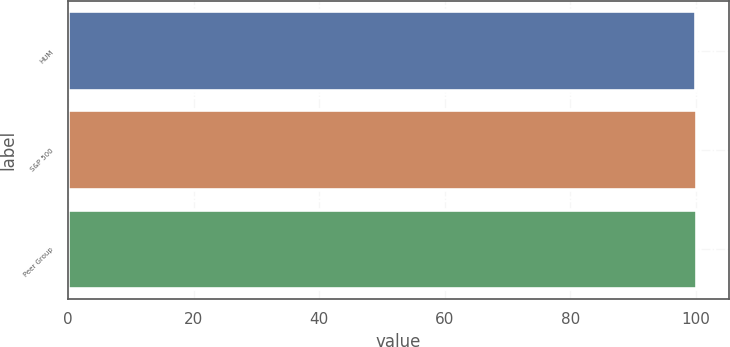Convert chart to OTSL. <chart><loc_0><loc_0><loc_500><loc_500><bar_chart><fcel>HUM<fcel>S&P 500<fcel>Peer Group<nl><fcel>100<fcel>100.1<fcel>100.2<nl></chart> 